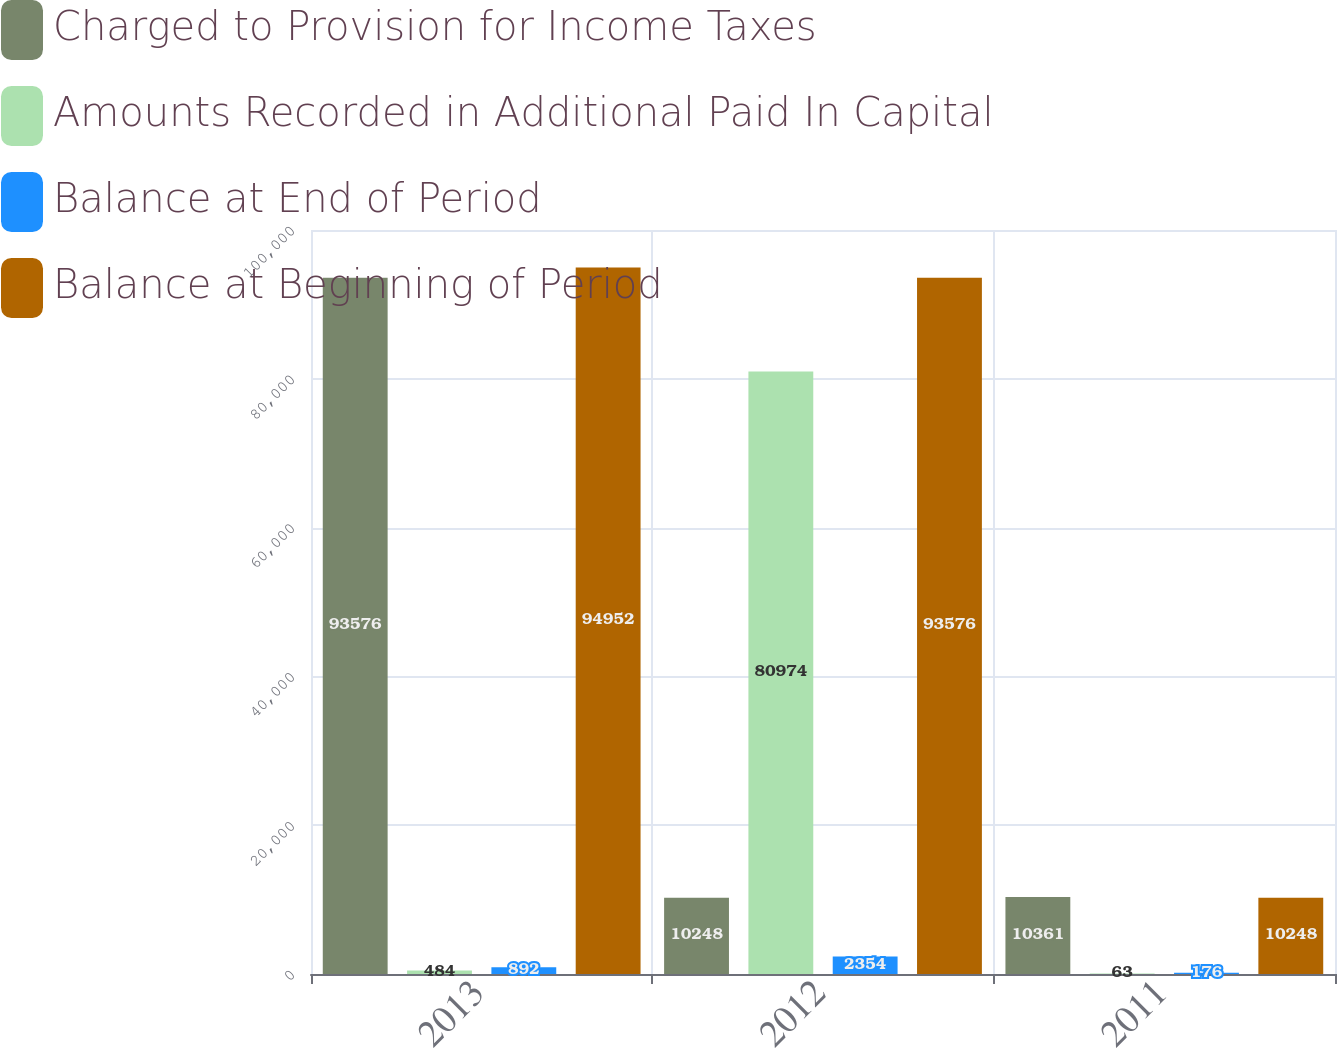Convert chart to OTSL. <chart><loc_0><loc_0><loc_500><loc_500><stacked_bar_chart><ecel><fcel>2013<fcel>2012<fcel>2011<nl><fcel>Charged to Provision for Income Taxes<fcel>93576<fcel>10248<fcel>10361<nl><fcel>Amounts Recorded in Additional Paid In Capital<fcel>484<fcel>80974<fcel>63<nl><fcel>Balance at End of Period<fcel>892<fcel>2354<fcel>176<nl><fcel>Balance at Beginning of Period<fcel>94952<fcel>93576<fcel>10248<nl></chart> 